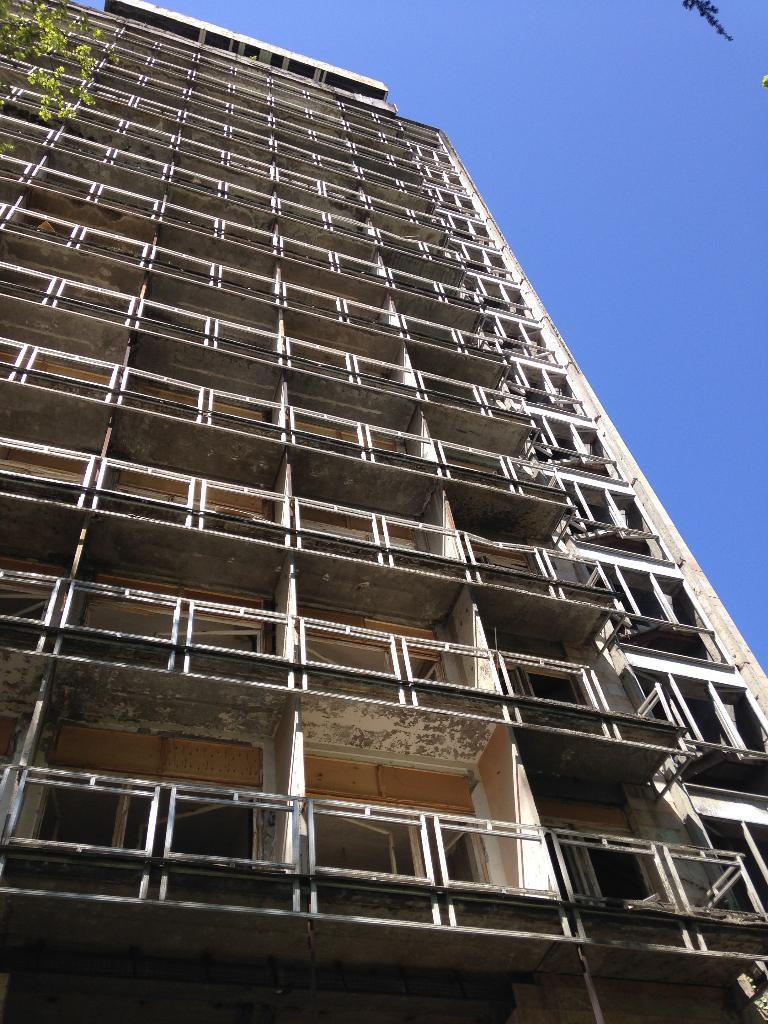What type of structure is present in the image? There is a building in the image. What feature of the building is mentioned in the facts? The building has many windows. What can be seen in the background of the image? There is a sky visible in the image. What type of vegetation is present in the image? There is a tree in the image. Where is the baby's knee located in the image? There is no baby or knee present in the image. 